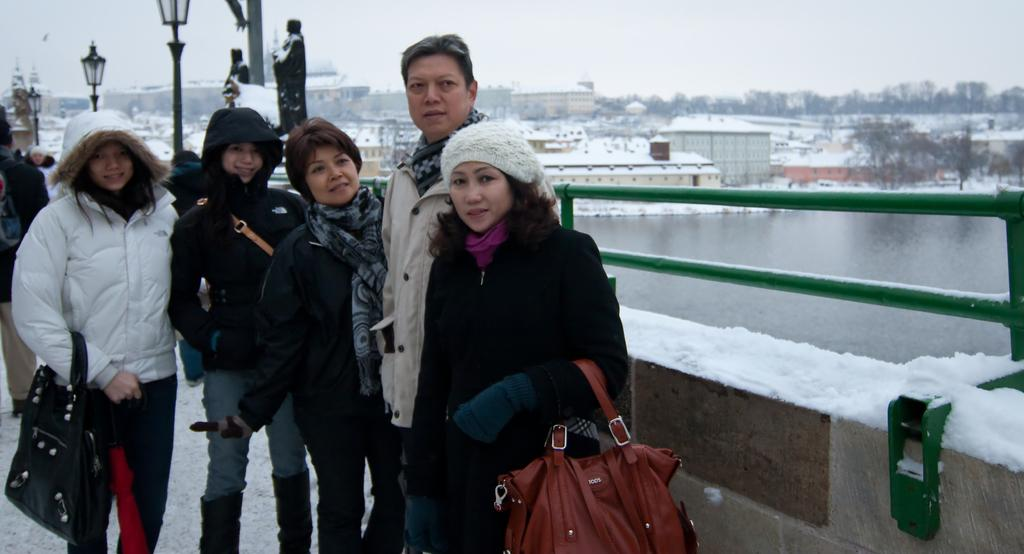How many people are present in the image? There are several people standing in the image. What can be seen in the background of the image? There are buildings in the background of the image. What is the condition of the buildings in the image? The buildings are covered with snow. What type of flower is blooming in the image? There is no flower present in the image. Can you see the people's breath in the image? The image does not provide enough information to determine if the people's breath is visible. 